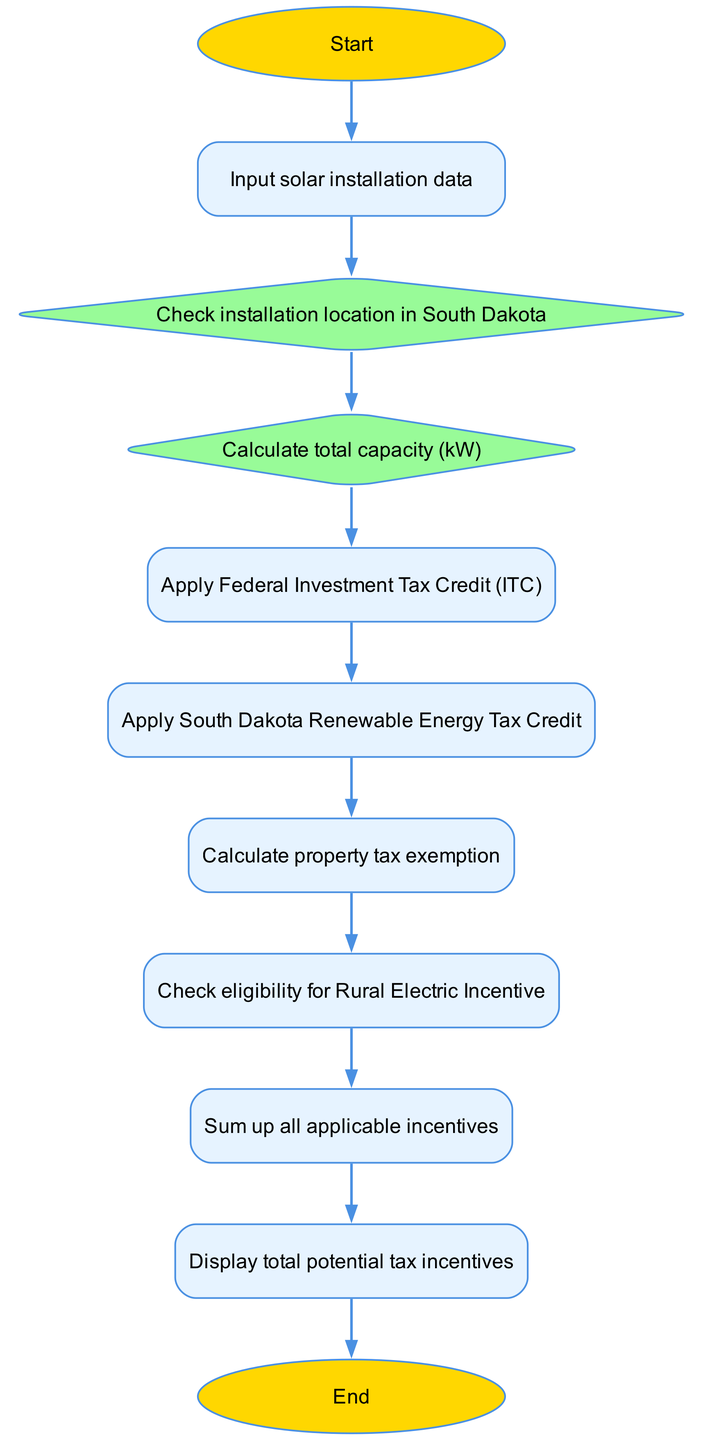What is the first step in the diagram? The diagram begins with the "Start" node, which indicates the initiation of the process. This is the first element in the flowchart.
Answer: Start How many total nodes are present in the diagram? There are eleven nodes including the "Start" and "End" nodes, as well as the individual steps in the process of calculating tax incentives for solar installations.
Answer: Eleven What is the last action performed in the flowchart? The final action is represented by the "Display total potential tax incentives" node before reaching the "End" node, indicating the conclusion of the process.
Answer: Display total potential tax incentives Which node follows the "Check installation location in South Dakota" node? The node that follows "Check installation location in South Dakota" is "Calculate total capacity (kW)", indicating the next step after checking the location.
Answer: Calculate total capacity (kW) What incentives are applied after calculating the total capacity? After calculating the total capacity, the flow proceeds to applying the "Federal Investment Tax Credit (ITC)" and then the "South Dakota Renewable Energy Tax Credit" consecutively.
Answer: Federal Investment Tax Credit (ITC) and South Dakota Renewable Energy Tax Credit What is the purpose of the "Check eligibility for Rural Electric Incentive" node? This node assesses whether the solar installation qualifies for additional financial support through the Rural Electric Incentive, which can provide additional benefits.
Answer: Assess eligibility for additional financial support How are the total incentives determined in the flowchart? Total incentives are determined by summing up all applicable incentives after calculating specific incentives like federal tax credit, state tax credit, and property tax exemption sequentially.
Answer: Sum up all applicable incentives What type of shape represents decision points in the flowchart? Decision points in the flowchart are represented by diamond shapes, which indicate places where a decision or check is made, such as location checks and eligibility assessments.
Answer: Diamond shapes 